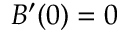<formula> <loc_0><loc_0><loc_500><loc_500>B ^ { \prime } ( 0 ) = 0</formula> 